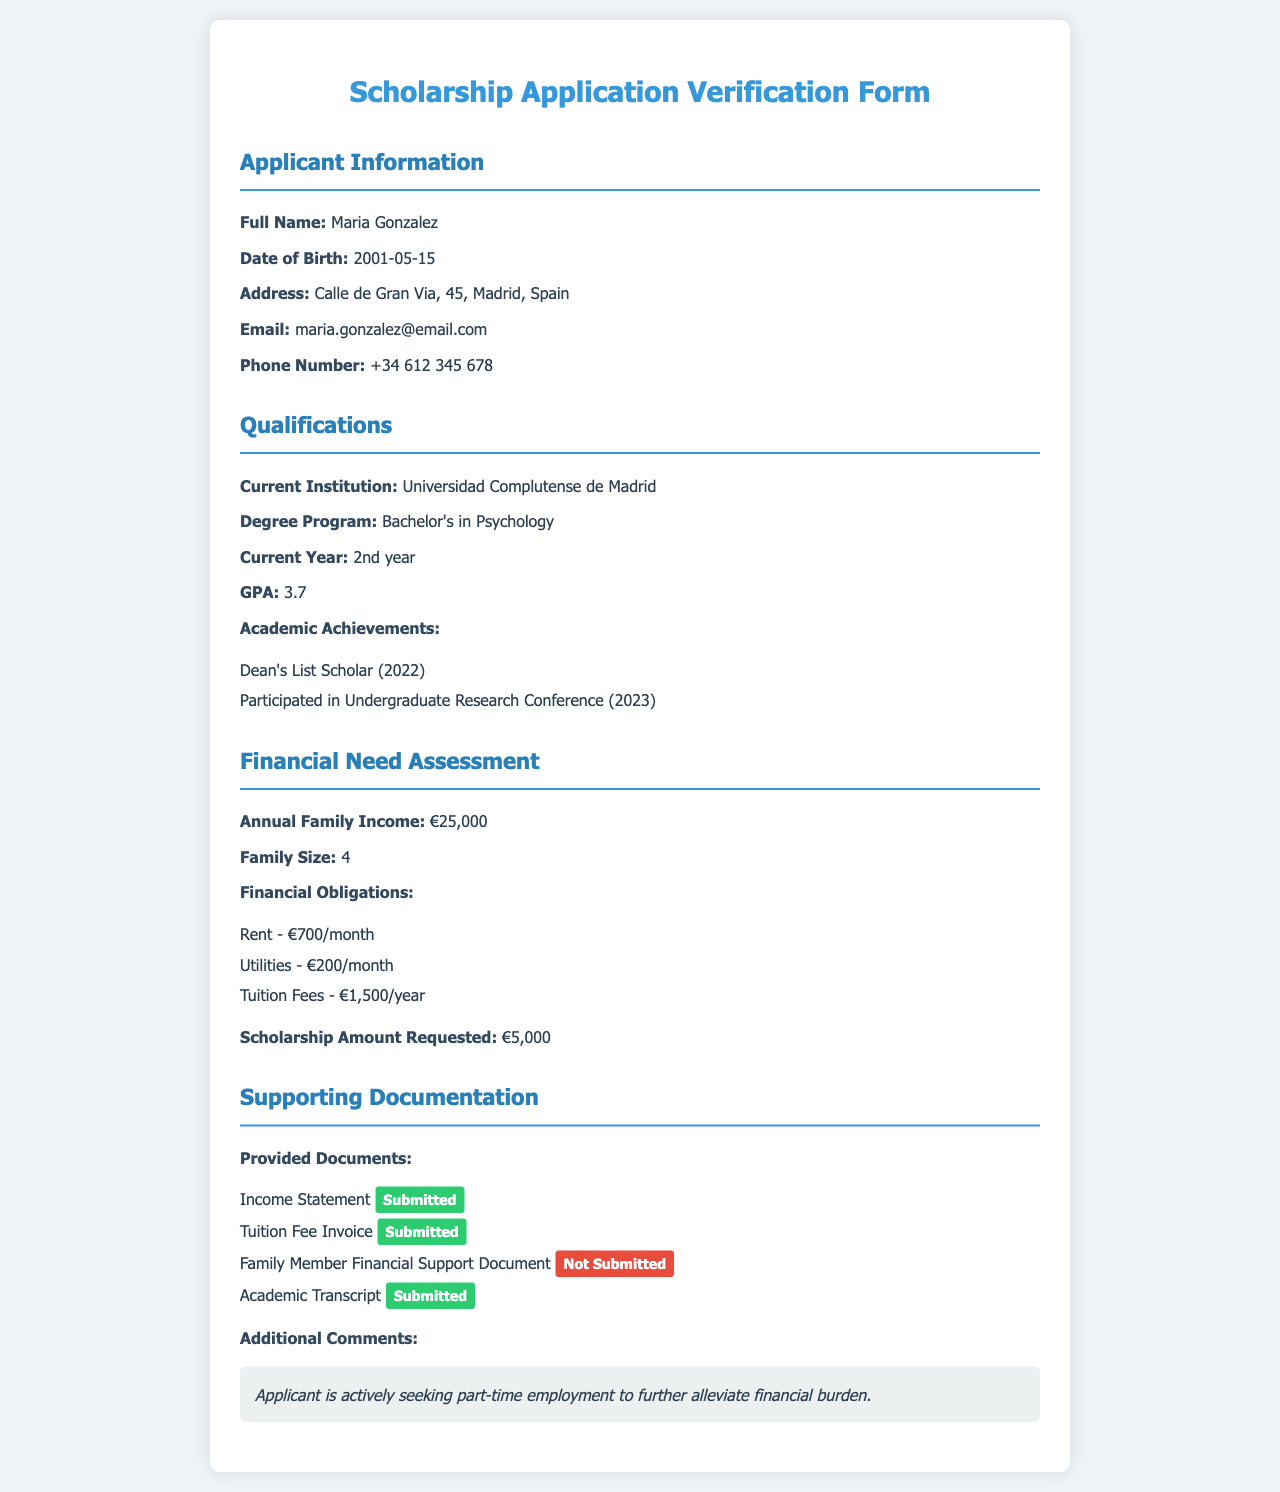What is the applicant's full name? The applicant's full name is provided at the beginning of the document under the Applicant Information section.
Answer: Maria Gonzalez What degree program is the applicant pursuing? The degree program is mentioned under the Qualifications section, indicating the field of study.
Answer: Bachelor's in Psychology What is the applicant's GPA? The GPA is listed directly under the Qualifications section, providing a measure of academic performance.
Answer: 3.7 What is the annual family income stated in the application? The annual family income is found in the Financial Need Assessment section, detailing financial circumstances.
Answer: €25,000 How many family members are included in the family size? The family size is mentioned in the Financial Need Assessment section, giving insight into the applicant's household.
Answer: 4 What is the total monthly cost of rent and utilities? The total monthly cost is calculated by summing the rent and utilities listed in Financial Obligations.
Answer: €900/month What is the amount of scholarship requested by the applicant? The requested scholarship amount is provided explicitly in the Financial Need Assessment section.
Answer: €5,000 How many documents were submitted by the applicant? The number of submitted documents is counted from the Provided Documents list under Supporting Documentation.
Answer: 3 What additional step is the applicant taking to alleviate financial burden? The additional step is mentioned in the Additional Comments section regarding the applicant's efforts.
Answer: Seeking part-time employment 